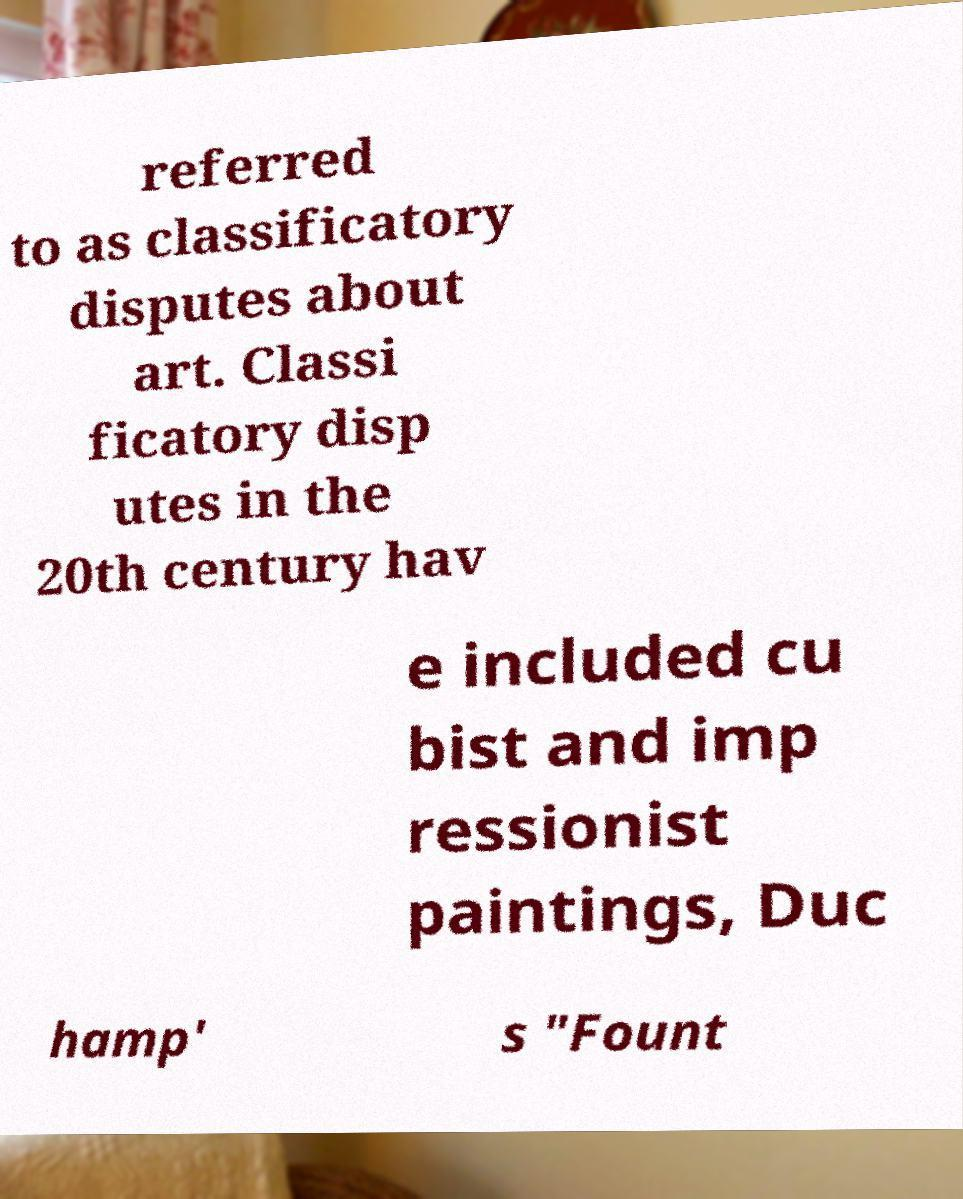For documentation purposes, I need the text within this image transcribed. Could you provide that? referred to as classificatory disputes about art. Classi ficatory disp utes in the 20th century hav e included cu bist and imp ressionist paintings, Duc hamp' s "Fount 